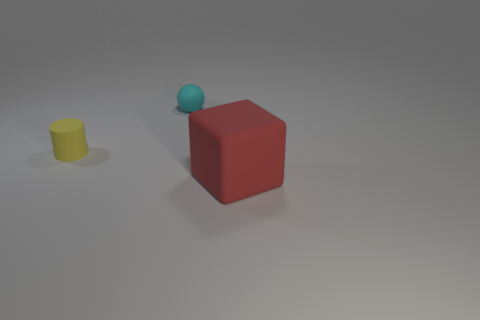How many tiny things are either yellow things or red shiny blocks?
Your answer should be very brief. 1. Is the number of tiny cyan balls to the right of the large red matte object greater than the number of tiny matte cylinders in front of the yellow thing?
Provide a succinct answer. No. Do the tiny yellow cylinder and the object that is to the right of the cyan sphere have the same material?
Provide a short and direct response. Yes. The small sphere is what color?
Ensure brevity in your answer.  Cyan. What is the shape of the tiny rubber object behind the tiny yellow object?
Keep it short and to the point. Sphere. How many green things are matte objects or matte cylinders?
Your response must be concise. 0. The small cylinder that is made of the same material as the big block is what color?
Make the answer very short. Yellow. There is a matte cylinder; does it have the same color as the object right of the cyan rubber thing?
Offer a terse response. No. What color is the matte thing that is both in front of the tiny ball and right of the yellow cylinder?
Provide a succinct answer. Red. What number of red matte objects are right of the small cyan matte object?
Provide a succinct answer. 1. 